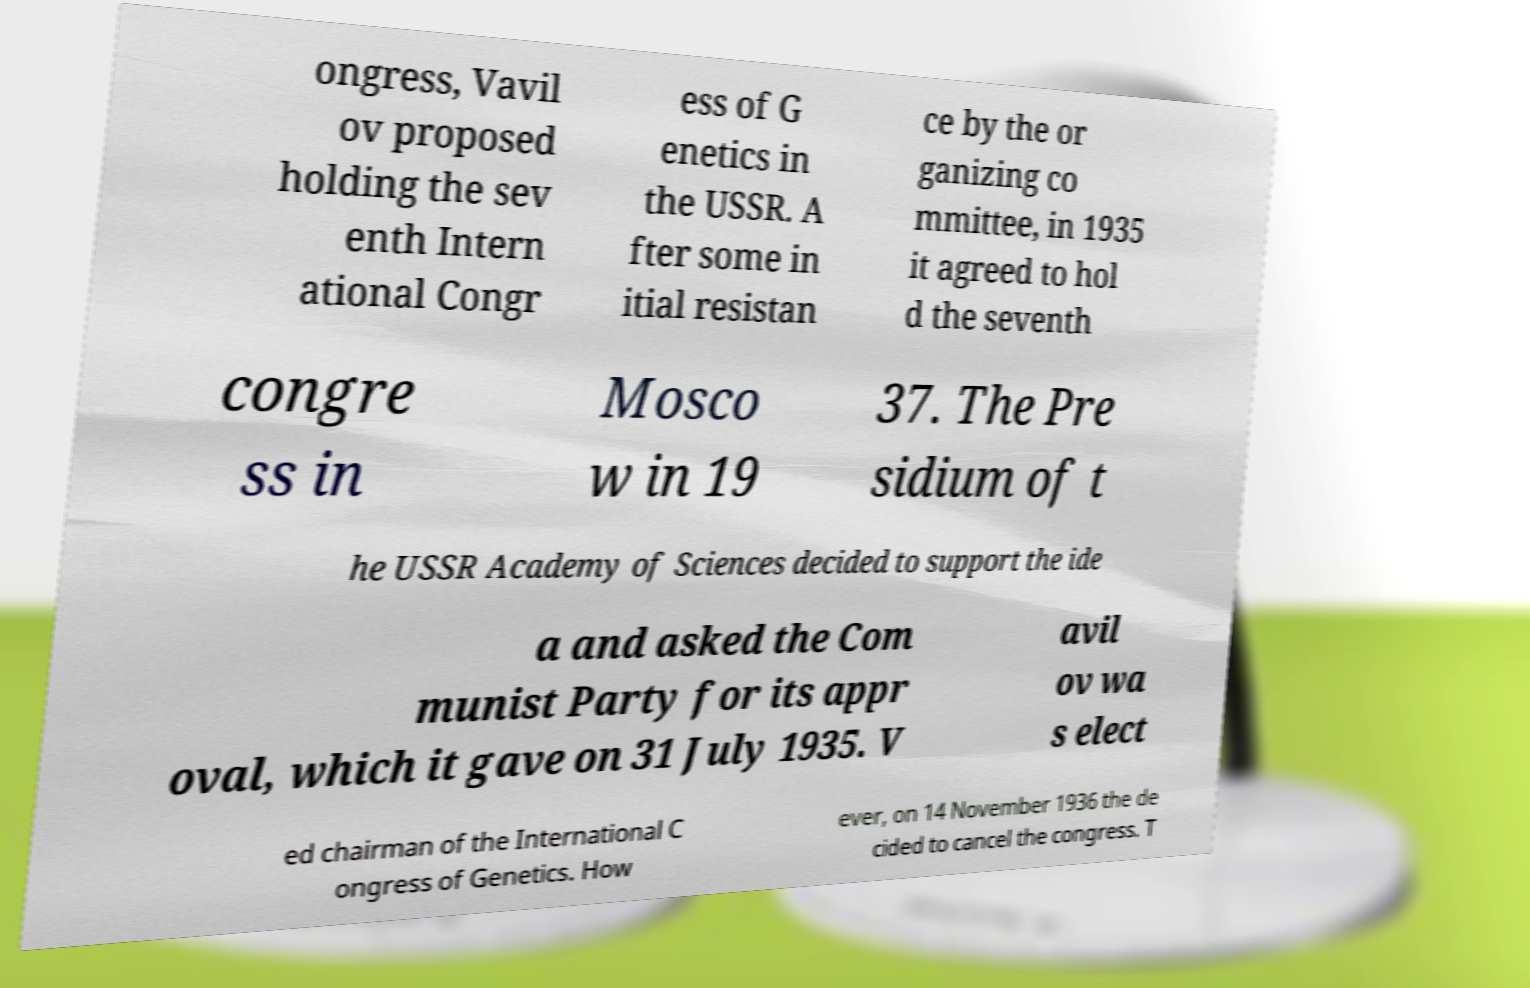Could you assist in decoding the text presented in this image and type it out clearly? ongress, Vavil ov proposed holding the sev enth Intern ational Congr ess of G enetics in the USSR. A fter some in itial resistan ce by the or ganizing co mmittee, in 1935 it agreed to hol d the seventh congre ss in Mosco w in 19 37. The Pre sidium of t he USSR Academy of Sciences decided to support the ide a and asked the Com munist Party for its appr oval, which it gave on 31 July 1935. V avil ov wa s elect ed chairman of the International C ongress of Genetics. How ever, on 14 November 1936 the de cided to cancel the congress. T 